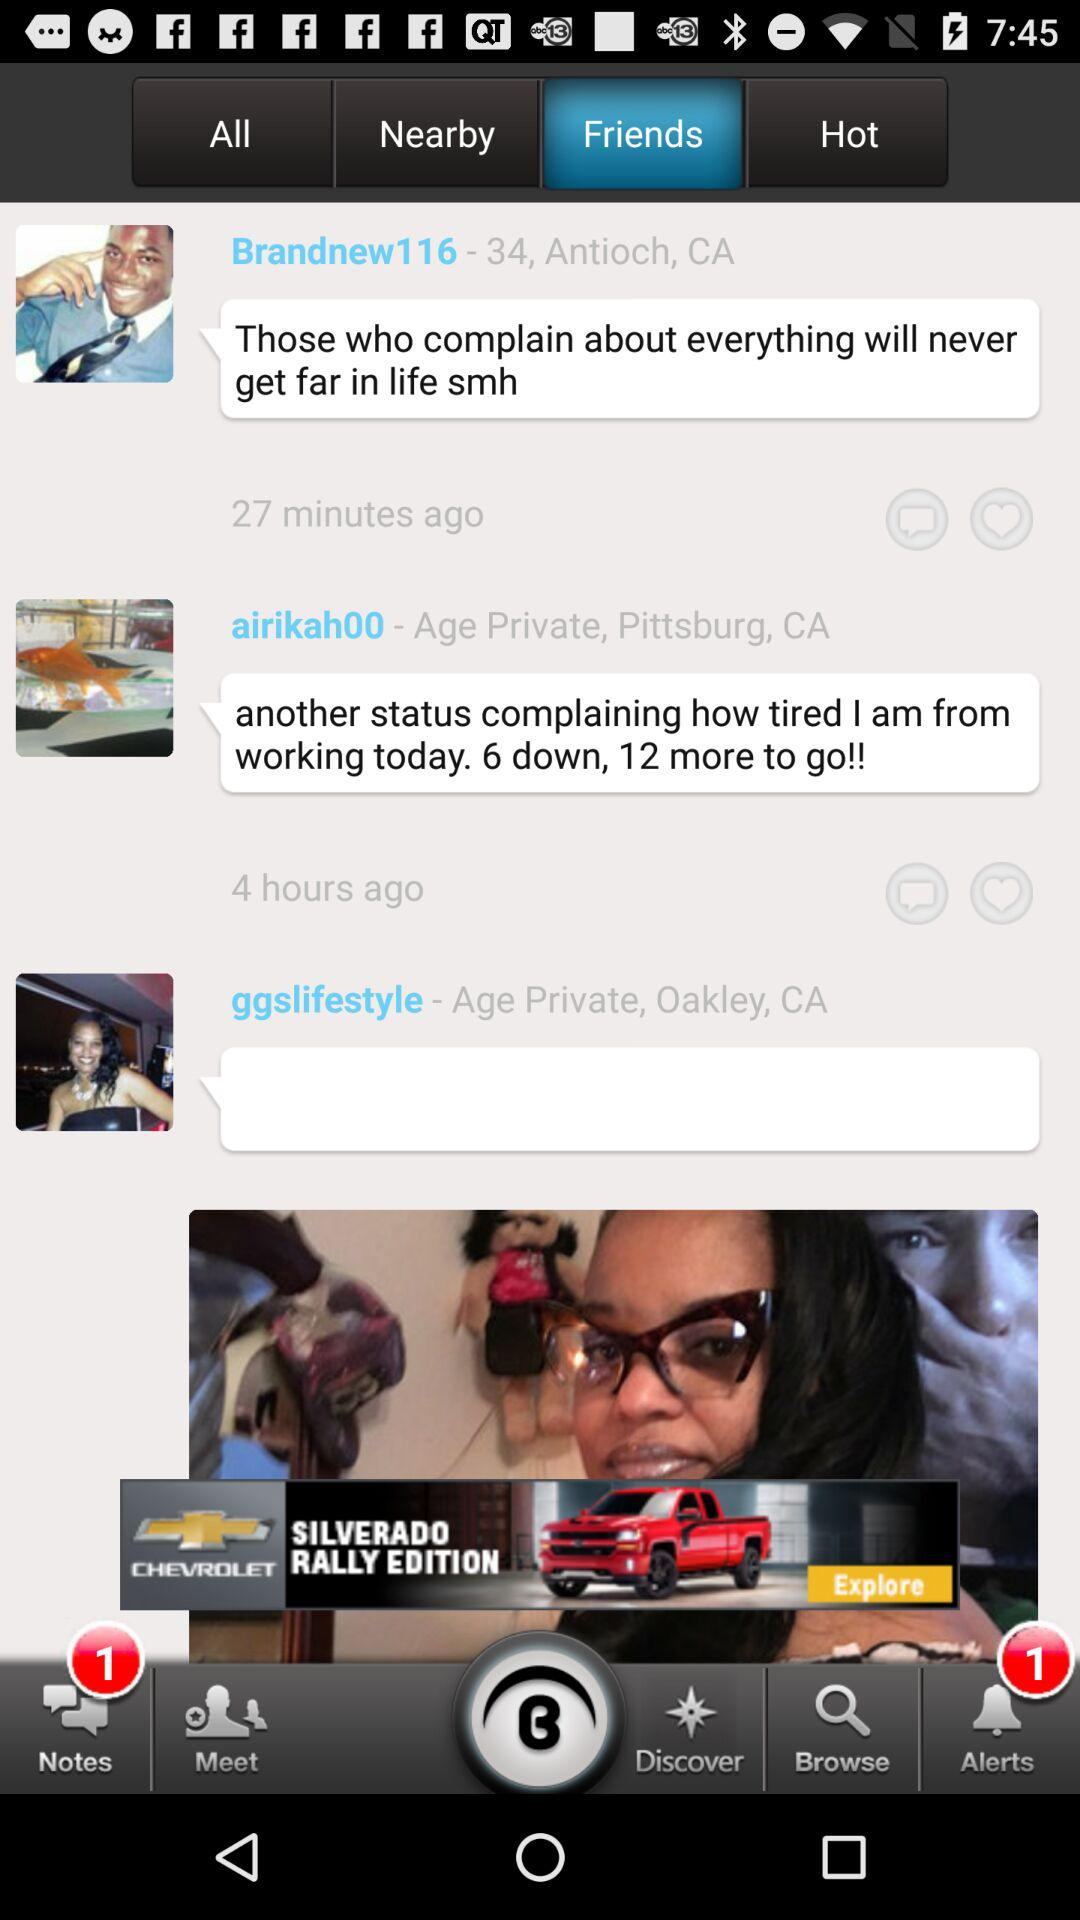Which tab has been selected? The selected tab is "Friends". 